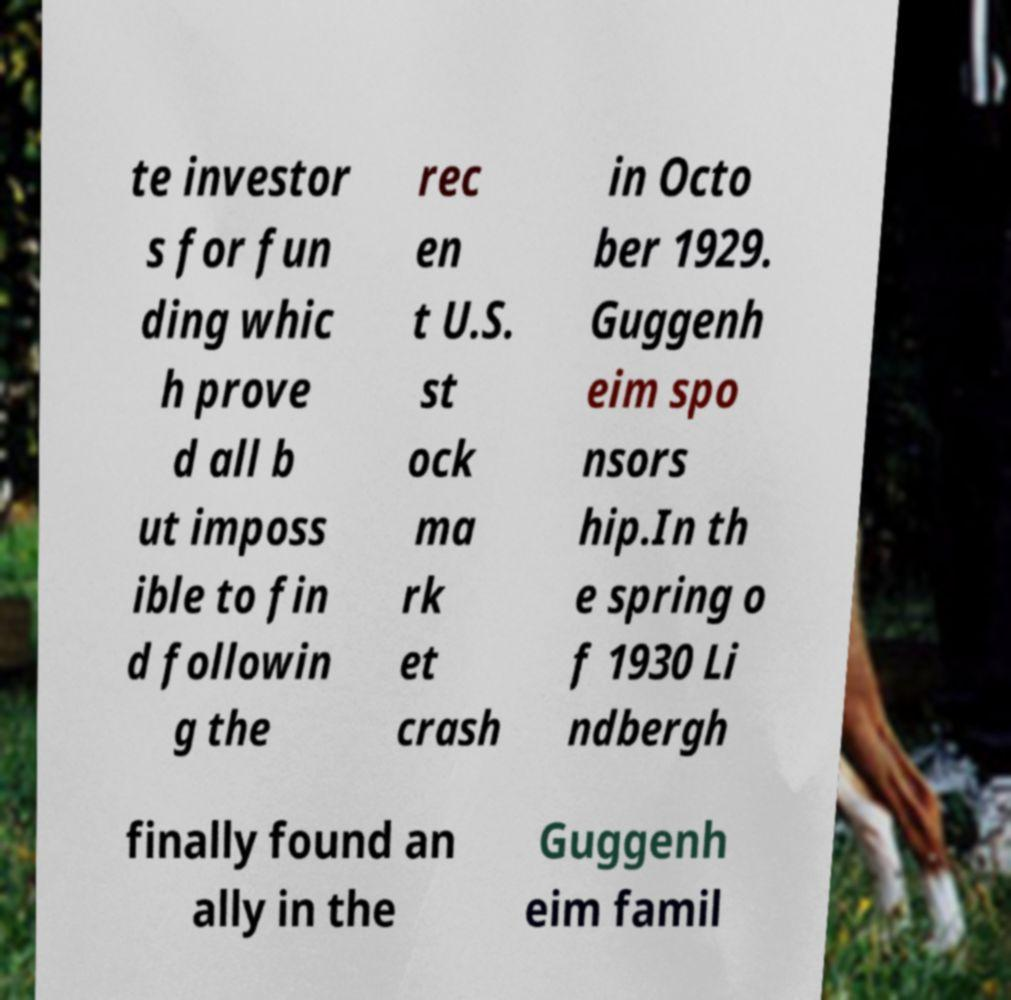Please identify and transcribe the text found in this image. te investor s for fun ding whic h prove d all b ut imposs ible to fin d followin g the rec en t U.S. st ock ma rk et crash in Octo ber 1929. Guggenh eim spo nsors hip.In th e spring o f 1930 Li ndbergh finally found an ally in the Guggenh eim famil 